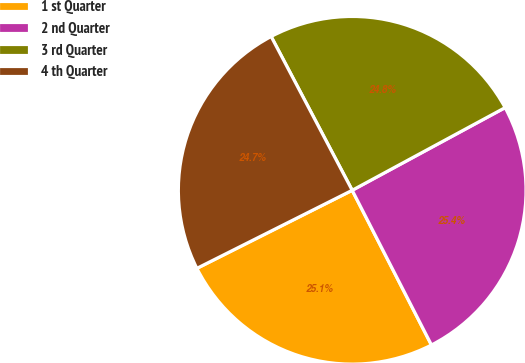<chart> <loc_0><loc_0><loc_500><loc_500><pie_chart><fcel>1 st Quarter<fcel>2 nd Quarter<fcel>3 rd Quarter<fcel>4 th Quarter<nl><fcel>25.12%<fcel>25.35%<fcel>24.83%<fcel>24.69%<nl></chart> 